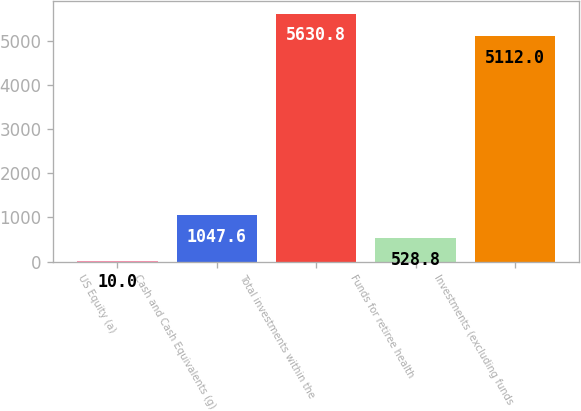<chart> <loc_0><loc_0><loc_500><loc_500><bar_chart><fcel>US Equity (a)<fcel>Cash and Cash Equivalents (g)<fcel>Total investments within the<fcel>Funds for retiree health<fcel>Investments (excluding funds<nl><fcel>10<fcel>1047.6<fcel>5630.8<fcel>528.8<fcel>5112<nl></chart> 